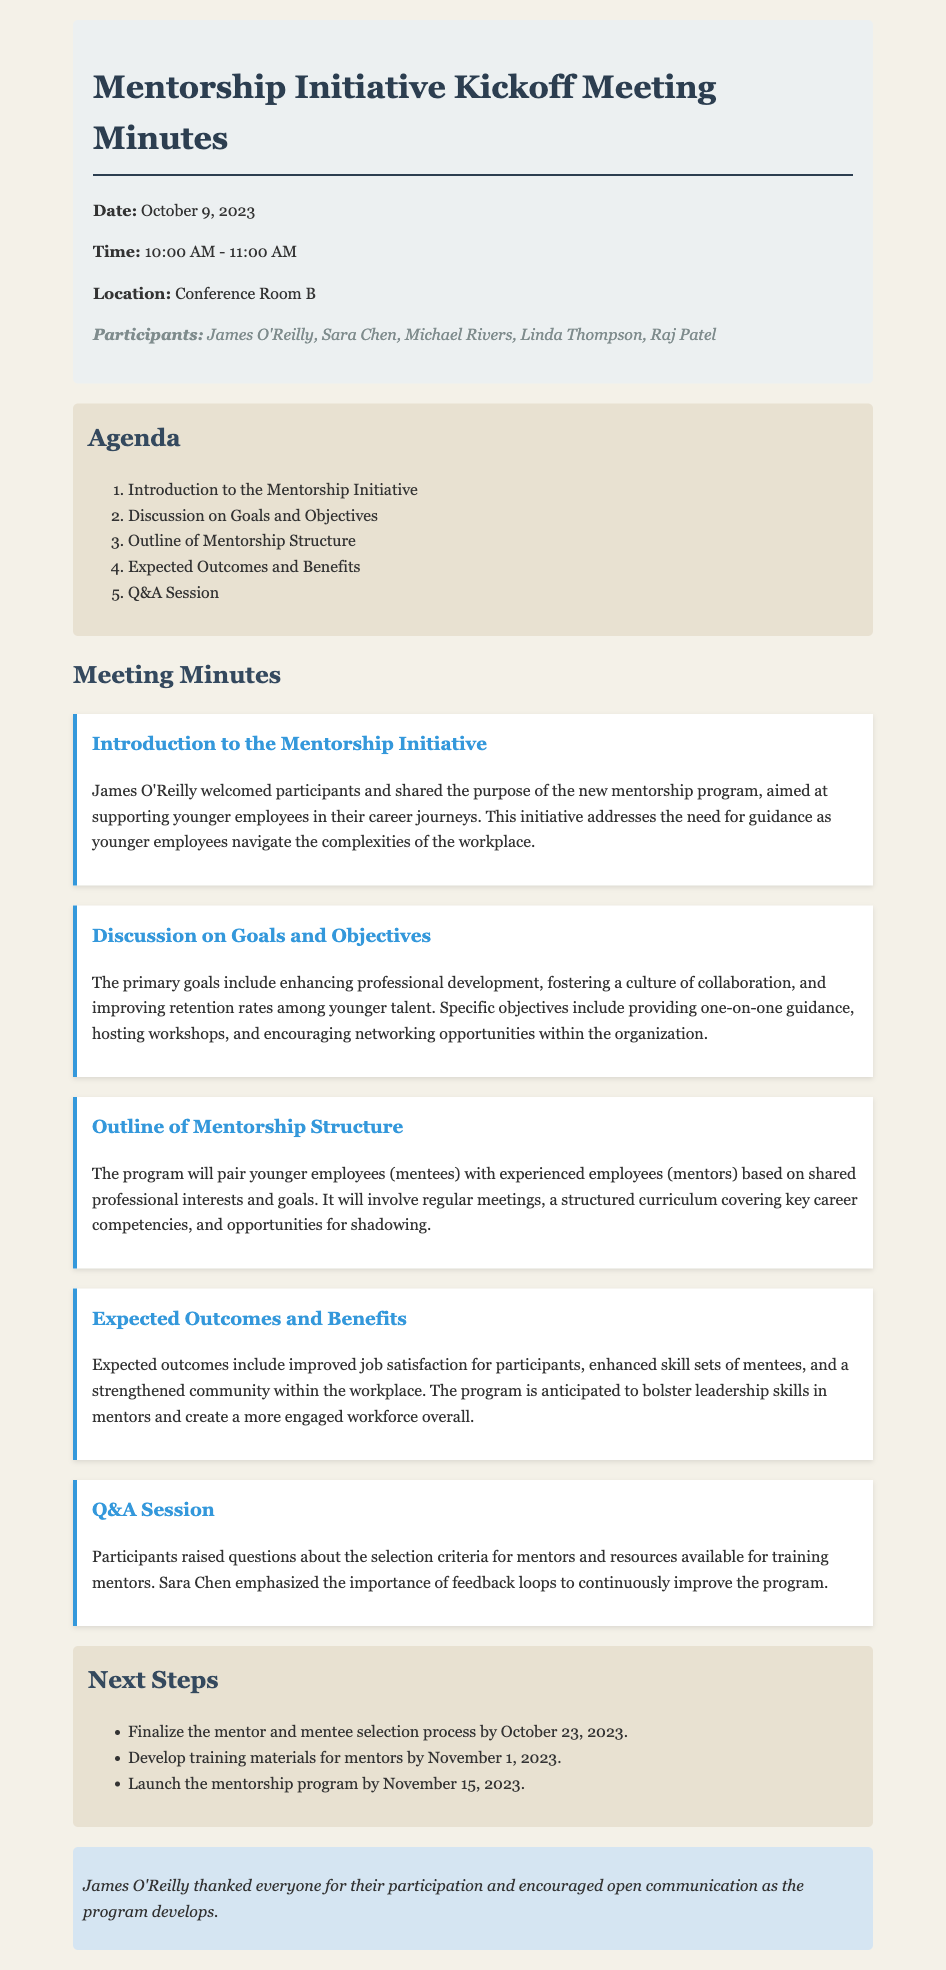What is the date of the meeting? The date of the meeting is explicitly stated at the beginning of the document.
Answer: October 9, 2023 Who welcomed the participants to the meeting? James O'Reilly is mentioned as the person who welcomed participants.
Answer: James O'Reilly What are the primary goals of the mentorship program? The document outlines the primary goals which are related to professional development and collaboration.
Answer: Enhancing professional development What is the deadline for finalizing the mentor and mentee selection process? This information is included in the next steps section where specific dates are provided.
Answer: October 23, 2023 What will the mentors and mentees be paired based on? The pairing criteria is discussed in the section outlining the mentorship structure.
Answer: Shared professional interests and goals What type of curriculum will the mentorship program include? The document specifies the curriculum type as it relates to the mentorship program structure.
Answer: Key career competencies How many participants were in the meeting? The list of participants is included at the beginning of the document which allows for easy counting.
Answer: Five What is one expected outcome of the mentorship program? Expected outcomes are detailed in a specific section of the minutes, addressing the benefits of the program.
Answer: Improved job satisfaction What did Sara Chen emphasize during the Q&A session? The emphasis made by Sara Chen is noted in the minutes regarding the program’s improvement.
Answer: Importance of feedback loops 